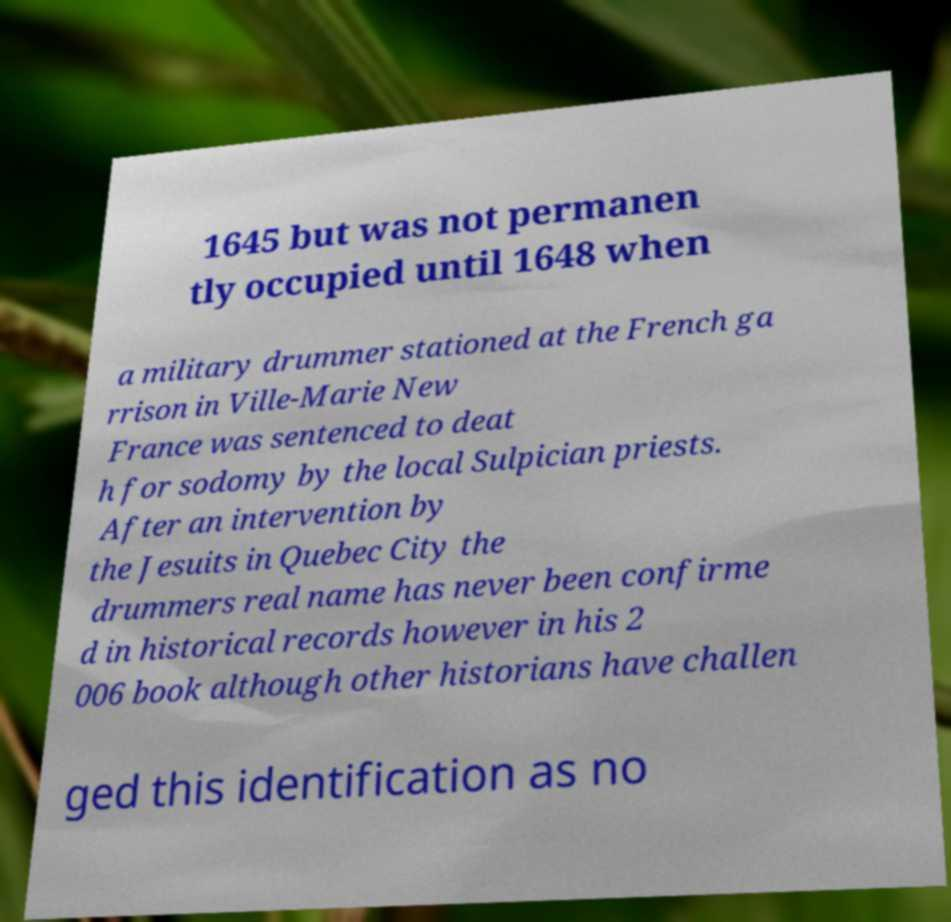There's text embedded in this image that I need extracted. Can you transcribe it verbatim? 1645 but was not permanen tly occupied until 1648 when a military drummer stationed at the French ga rrison in Ville-Marie New France was sentenced to deat h for sodomy by the local Sulpician priests. After an intervention by the Jesuits in Quebec City the drummers real name has never been confirme d in historical records however in his 2 006 book although other historians have challen ged this identification as no 